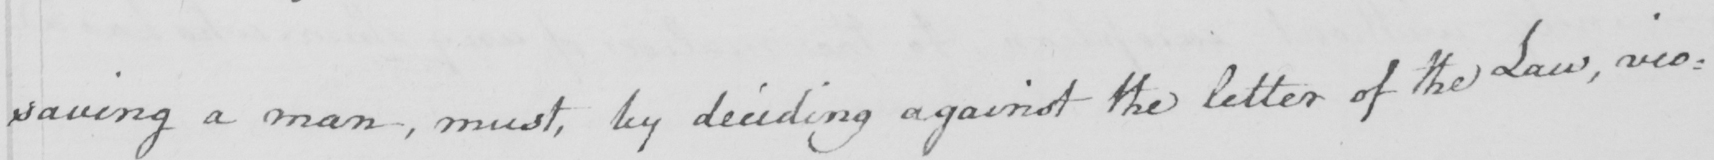What is written in this line of handwriting? saving a man , must , by deciding against the letter of the Law , vio= 